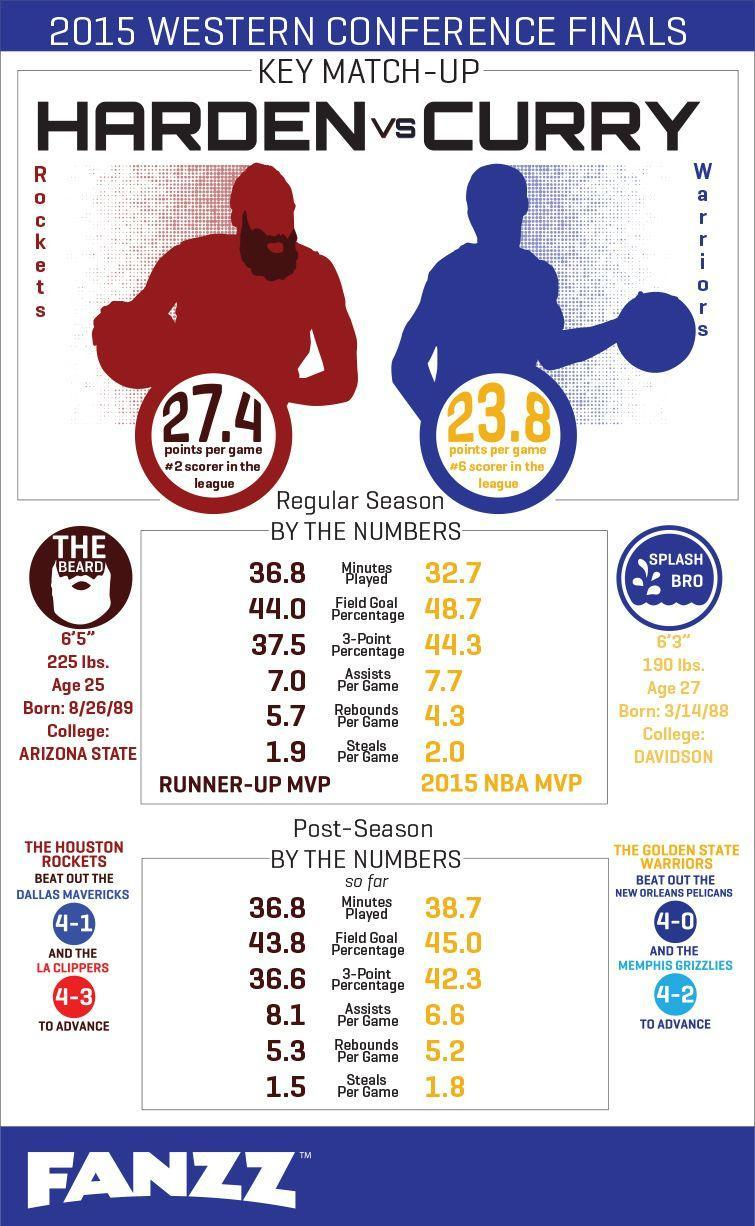What was the weight of The Beard
Answer the question with a short phrase. 225 lbs Which teams did the golden state warriors beat out new orleans pelicans, memphis grizzlies What was the weight of Splash Bro 190 lbs How tall is Splash Bro 6'3" which teams did the houston rockets beat out dallas mavericks, la clippers What is the 3 point percertage of The Golden State Warriors 42.3 How many minutes did The Houston play 36.8 How tall is The Beard 6'5" 